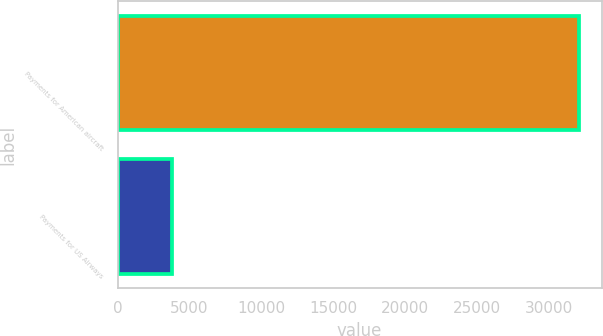<chart> <loc_0><loc_0><loc_500><loc_500><bar_chart><fcel>Payments for American aircraft<fcel>Payments for US Airways<nl><fcel>32073<fcel>3818<nl></chart> 